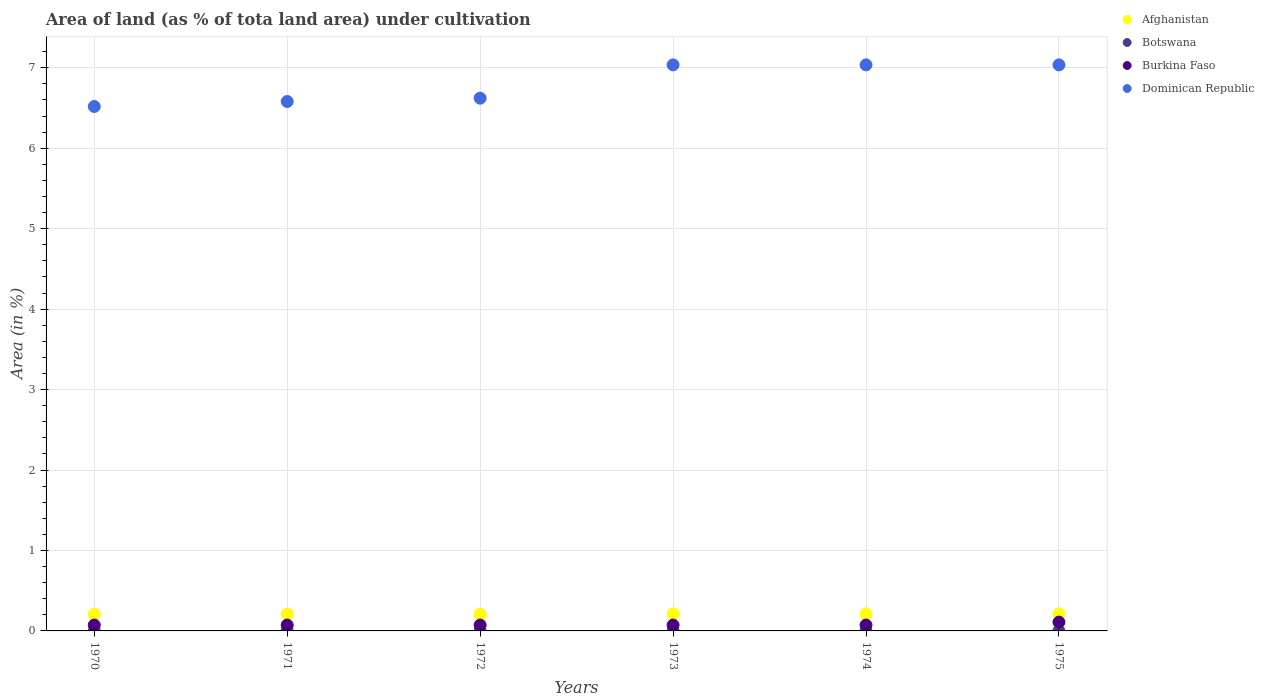What is the percentage of land under cultivation in Botswana in 1974?
Your answer should be compact. 0. Across all years, what is the maximum percentage of land under cultivation in Afghanistan?
Your response must be concise. 0.21. Across all years, what is the minimum percentage of land under cultivation in Dominican Republic?
Offer a terse response. 6.52. What is the total percentage of land under cultivation in Afghanistan in the graph?
Your answer should be very brief. 1.26. What is the difference between the percentage of land under cultivation in Afghanistan in 1973 and that in 1974?
Offer a terse response. 0. What is the difference between the percentage of land under cultivation in Burkina Faso in 1972 and the percentage of land under cultivation in Afghanistan in 1974?
Your response must be concise. -0.14. What is the average percentage of land under cultivation in Burkina Faso per year?
Your answer should be compact. 0.08. In the year 1973, what is the difference between the percentage of land under cultivation in Burkina Faso and percentage of land under cultivation in Dominican Republic?
Provide a short and direct response. -6.96. Is the difference between the percentage of land under cultivation in Burkina Faso in 1972 and 1975 greater than the difference between the percentage of land under cultivation in Dominican Republic in 1972 and 1975?
Provide a succinct answer. Yes. What is the difference between the highest and the second highest percentage of land under cultivation in Burkina Faso?
Your response must be concise. 0.04. In how many years, is the percentage of land under cultivation in Afghanistan greater than the average percentage of land under cultivation in Afghanistan taken over all years?
Provide a short and direct response. 3. Is the sum of the percentage of land under cultivation in Afghanistan in 1970 and 1974 greater than the maximum percentage of land under cultivation in Dominican Republic across all years?
Offer a terse response. No. Is it the case that in every year, the sum of the percentage of land under cultivation in Burkina Faso and percentage of land under cultivation in Dominican Republic  is greater than the sum of percentage of land under cultivation in Botswana and percentage of land under cultivation in Afghanistan?
Your answer should be very brief. No. Is it the case that in every year, the sum of the percentage of land under cultivation in Afghanistan and percentage of land under cultivation in Burkina Faso  is greater than the percentage of land under cultivation in Dominican Republic?
Keep it short and to the point. No. Is the percentage of land under cultivation in Botswana strictly greater than the percentage of land under cultivation in Burkina Faso over the years?
Provide a short and direct response. No. How many dotlines are there?
Provide a succinct answer. 4. How many years are there in the graph?
Provide a short and direct response. 6. Does the graph contain grids?
Your response must be concise. Yes. Where does the legend appear in the graph?
Your response must be concise. Top right. How many legend labels are there?
Ensure brevity in your answer.  4. How are the legend labels stacked?
Make the answer very short. Vertical. What is the title of the graph?
Provide a short and direct response. Area of land (as % of tota land area) under cultivation. Does "Samoa" appear as one of the legend labels in the graph?
Keep it short and to the point. No. What is the label or title of the X-axis?
Your response must be concise. Years. What is the label or title of the Y-axis?
Your response must be concise. Area (in %). What is the Area (in %) of Afghanistan in 1970?
Keep it short and to the point. 0.21. What is the Area (in %) in Botswana in 1970?
Offer a terse response. 0. What is the Area (in %) in Burkina Faso in 1970?
Your answer should be compact. 0.07. What is the Area (in %) in Dominican Republic in 1970?
Offer a terse response. 6.52. What is the Area (in %) in Afghanistan in 1971?
Your answer should be very brief. 0.21. What is the Area (in %) of Botswana in 1971?
Your answer should be compact. 0. What is the Area (in %) of Burkina Faso in 1971?
Provide a short and direct response. 0.07. What is the Area (in %) of Dominican Republic in 1971?
Make the answer very short. 6.58. What is the Area (in %) in Afghanistan in 1972?
Make the answer very short. 0.21. What is the Area (in %) in Botswana in 1972?
Your answer should be compact. 0. What is the Area (in %) of Burkina Faso in 1972?
Give a very brief answer. 0.07. What is the Area (in %) in Dominican Republic in 1972?
Make the answer very short. 6.62. What is the Area (in %) in Afghanistan in 1973?
Offer a terse response. 0.21. What is the Area (in %) in Botswana in 1973?
Provide a short and direct response. 0. What is the Area (in %) of Burkina Faso in 1973?
Provide a short and direct response. 0.07. What is the Area (in %) of Dominican Republic in 1973?
Give a very brief answer. 7.04. What is the Area (in %) of Afghanistan in 1974?
Keep it short and to the point. 0.21. What is the Area (in %) in Botswana in 1974?
Keep it short and to the point. 0. What is the Area (in %) in Burkina Faso in 1974?
Make the answer very short. 0.07. What is the Area (in %) of Dominican Republic in 1974?
Your answer should be compact. 7.04. What is the Area (in %) of Afghanistan in 1975?
Offer a terse response. 0.21. What is the Area (in %) in Botswana in 1975?
Provide a succinct answer. 0. What is the Area (in %) of Burkina Faso in 1975?
Ensure brevity in your answer.  0.11. What is the Area (in %) of Dominican Republic in 1975?
Ensure brevity in your answer.  7.04. Across all years, what is the maximum Area (in %) in Afghanistan?
Ensure brevity in your answer.  0.21. Across all years, what is the maximum Area (in %) in Botswana?
Provide a short and direct response. 0. Across all years, what is the maximum Area (in %) of Burkina Faso?
Offer a very short reply. 0.11. Across all years, what is the maximum Area (in %) of Dominican Republic?
Your answer should be compact. 7.04. Across all years, what is the minimum Area (in %) of Afghanistan?
Provide a succinct answer. 0.21. Across all years, what is the minimum Area (in %) of Botswana?
Give a very brief answer. 0. Across all years, what is the minimum Area (in %) in Burkina Faso?
Provide a short and direct response. 0.07. Across all years, what is the minimum Area (in %) in Dominican Republic?
Your answer should be very brief. 6.52. What is the total Area (in %) of Afghanistan in the graph?
Give a very brief answer. 1.26. What is the total Area (in %) of Botswana in the graph?
Your answer should be very brief. 0.01. What is the total Area (in %) in Burkina Faso in the graph?
Make the answer very short. 0.48. What is the total Area (in %) in Dominican Republic in the graph?
Your answer should be very brief. 40.83. What is the difference between the Area (in %) in Afghanistan in 1970 and that in 1971?
Your answer should be compact. 0. What is the difference between the Area (in %) in Botswana in 1970 and that in 1971?
Provide a succinct answer. 0. What is the difference between the Area (in %) of Burkina Faso in 1970 and that in 1971?
Keep it short and to the point. 0. What is the difference between the Area (in %) of Dominican Republic in 1970 and that in 1971?
Offer a very short reply. -0.06. What is the difference between the Area (in %) in Botswana in 1970 and that in 1972?
Provide a short and direct response. 0. What is the difference between the Area (in %) in Burkina Faso in 1970 and that in 1972?
Your answer should be very brief. 0. What is the difference between the Area (in %) in Dominican Republic in 1970 and that in 1972?
Offer a very short reply. -0.1. What is the difference between the Area (in %) of Afghanistan in 1970 and that in 1973?
Provide a succinct answer. -0. What is the difference between the Area (in %) in Botswana in 1970 and that in 1973?
Offer a terse response. 0. What is the difference between the Area (in %) of Dominican Republic in 1970 and that in 1973?
Offer a very short reply. -0.52. What is the difference between the Area (in %) in Afghanistan in 1970 and that in 1974?
Provide a succinct answer. -0. What is the difference between the Area (in %) of Dominican Republic in 1970 and that in 1974?
Your answer should be compact. -0.52. What is the difference between the Area (in %) in Afghanistan in 1970 and that in 1975?
Ensure brevity in your answer.  -0. What is the difference between the Area (in %) in Botswana in 1970 and that in 1975?
Ensure brevity in your answer.  0. What is the difference between the Area (in %) in Burkina Faso in 1970 and that in 1975?
Offer a very short reply. -0.04. What is the difference between the Area (in %) in Dominican Republic in 1970 and that in 1975?
Your response must be concise. -0.52. What is the difference between the Area (in %) of Afghanistan in 1971 and that in 1972?
Make the answer very short. 0. What is the difference between the Area (in %) of Botswana in 1971 and that in 1972?
Give a very brief answer. 0. What is the difference between the Area (in %) in Dominican Republic in 1971 and that in 1972?
Provide a short and direct response. -0.04. What is the difference between the Area (in %) in Afghanistan in 1971 and that in 1973?
Offer a terse response. -0. What is the difference between the Area (in %) in Dominican Republic in 1971 and that in 1973?
Offer a terse response. -0.46. What is the difference between the Area (in %) in Afghanistan in 1971 and that in 1974?
Keep it short and to the point. -0. What is the difference between the Area (in %) in Botswana in 1971 and that in 1974?
Offer a terse response. 0. What is the difference between the Area (in %) of Burkina Faso in 1971 and that in 1974?
Your response must be concise. 0. What is the difference between the Area (in %) of Dominican Republic in 1971 and that in 1974?
Give a very brief answer. -0.46. What is the difference between the Area (in %) in Afghanistan in 1971 and that in 1975?
Ensure brevity in your answer.  -0. What is the difference between the Area (in %) in Burkina Faso in 1971 and that in 1975?
Provide a succinct answer. -0.04. What is the difference between the Area (in %) in Dominican Republic in 1971 and that in 1975?
Make the answer very short. -0.46. What is the difference between the Area (in %) in Afghanistan in 1972 and that in 1973?
Keep it short and to the point. -0. What is the difference between the Area (in %) of Dominican Republic in 1972 and that in 1973?
Your answer should be compact. -0.41. What is the difference between the Area (in %) in Afghanistan in 1972 and that in 1974?
Keep it short and to the point. -0. What is the difference between the Area (in %) in Botswana in 1972 and that in 1974?
Your answer should be compact. 0. What is the difference between the Area (in %) of Burkina Faso in 1972 and that in 1974?
Offer a very short reply. 0. What is the difference between the Area (in %) in Dominican Republic in 1972 and that in 1974?
Offer a very short reply. -0.41. What is the difference between the Area (in %) of Afghanistan in 1972 and that in 1975?
Keep it short and to the point. -0. What is the difference between the Area (in %) in Botswana in 1972 and that in 1975?
Offer a very short reply. 0. What is the difference between the Area (in %) in Burkina Faso in 1972 and that in 1975?
Provide a short and direct response. -0.04. What is the difference between the Area (in %) in Dominican Republic in 1972 and that in 1975?
Offer a terse response. -0.41. What is the difference between the Area (in %) in Afghanistan in 1973 and that in 1974?
Make the answer very short. 0. What is the difference between the Area (in %) in Burkina Faso in 1973 and that in 1974?
Offer a terse response. 0. What is the difference between the Area (in %) in Afghanistan in 1973 and that in 1975?
Offer a very short reply. 0. What is the difference between the Area (in %) of Burkina Faso in 1973 and that in 1975?
Offer a very short reply. -0.04. What is the difference between the Area (in %) in Afghanistan in 1974 and that in 1975?
Ensure brevity in your answer.  0. What is the difference between the Area (in %) of Botswana in 1974 and that in 1975?
Offer a terse response. 0. What is the difference between the Area (in %) of Burkina Faso in 1974 and that in 1975?
Offer a very short reply. -0.04. What is the difference between the Area (in %) of Afghanistan in 1970 and the Area (in %) of Botswana in 1971?
Your answer should be very brief. 0.21. What is the difference between the Area (in %) of Afghanistan in 1970 and the Area (in %) of Burkina Faso in 1971?
Provide a short and direct response. 0.14. What is the difference between the Area (in %) of Afghanistan in 1970 and the Area (in %) of Dominican Republic in 1971?
Provide a succinct answer. -6.37. What is the difference between the Area (in %) in Botswana in 1970 and the Area (in %) in Burkina Faso in 1971?
Your answer should be compact. -0.07. What is the difference between the Area (in %) in Botswana in 1970 and the Area (in %) in Dominican Republic in 1971?
Give a very brief answer. -6.58. What is the difference between the Area (in %) in Burkina Faso in 1970 and the Area (in %) in Dominican Republic in 1971?
Provide a succinct answer. -6.51. What is the difference between the Area (in %) of Afghanistan in 1970 and the Area (in %) of Botswana in 1972?
Offer a terse response. 0.21. What is the difference between the Area (in %) in Afghanistan in 1970 and the Area (in %) in Burkina Faso in 1972?
Ensure brevity in your answer.  0.14. What is the difference between the Area (in %) in Afghanistan in 1970 and the Area (in %) in Dominican Republic in 1972?
Make the answer very short. -6.41. What is the difference between the Area (in %) in Botswana in 1970 and the Area (in %) in Burkina Faso in 1972?
Make the answer very short. -0.07. What is the difference between the Area (in %) of Botswana in 1970 and the Area (in %) of Dominican Republic in 1972?
Keep it short and to the point. -6.62. What is the difference between the Area (in %) in Burkina Faso in 1970 and the Area (in %) in Dominican Republic in 1972?
Provide a short and direct response. -6.55. What is the difference between the Area (in %) in Afghanistan in 1970 and the Area (in %) in Botswana in 1973?
Offer a very short reply. 0.21. What is the difference between the Area (in %) of Afghanistan in 1970 and the Area (in %) of Burkina Faso in 1973?
Keep it short and to the point. 0.14. What is the difference between the Area (in %) in Afghanistan in 1970 and the Area (in %) in Dominican Republic in 1973?
Give a very brief answer. -6.83. What is the difference between the Area (in %) in Botswana in 1970 and the Area (in %) in Burkina Faso in 1973?
Offer a very short reply. -0.07. What is the difference between the Area (in %) in Botswana in 1970 and the Area (in %) in Dominican Republic in 1973?
Your response must be concise. -7.03. What is the difference between the Area (in %) of Burkina Faso in 1970 and the Area (in %) of Dominican Republic in 1973?
Offer a very short reply. -6.96. What is the difference between the Area (in %) in Afghanistan in 1970 and the Area (in %) in Botswana in 1974?
Your answer should be very brief. 0.21. What is the difference between the Area (in %) of Afghanistan in 1970 and the Area (in %) of Burkina Faso in 1974?
Provide a succinct answer. 0.14. What is the difference between the Area (in %) in Afghanistan in 1970 and the Area (in %) in Dominican Republic in 1974?
Provide a succinct answer. -6.83. What is the difference between the Area (in %) in Botswana in 1970 and the Area (in %) in Burkina Faso in 1974?
Provide a short and direct response. -0.07. What is the difference between the Area (in %) of Botswana in 1970 and the Area (in %) of Dominican Republic in 1974?
Your response must be concise. -7.03. What is the difference between the Area (in %) of Burkina Faso in 1970 and the Area (in %) of Dominican Republic in 1974?
Give a very brief answer. -6.96. What is the difference between the Area (in %) of Afghanistan in 1970 and the Area (in %) of Botswana in 1975?
Keep it short and to the point. 0.21. What is the difference between the Area (in %) of Afghanistan in 1970 and the Area (in %) of Burkina Faso in 1975?
Make the answer very short. 0.1. What is the difference between the Area (in %) of Afghanistan in 1970 and the Area (in %) of Dominican Republic in 1975?
Your answer should be compact. -6.83. What is the difference between the Area (in %) of Botswana in 1970 and the Area (in %) of Burkina Faso in 1975?
Your response must be concise. -0.11. What is the difference between the Area (in %) in Botswana in 1970 and the Area (in %) in Dominican Republic in 1975?
Provide a succinct answer. -7.03. What is the difference between the Area (in %) of Burkina Faso in 1970 and the Area (in %) of Dominican Republic in 1975?
Ensure brevity in your answer.  -6.96. What is the difference between the Area (in %) of Afghanistan in 1971 and the Area (in %) of Botswana in 1972?
Keep it short and to the point. 0.21. What is the difference between the Area (in %) of Afghanistan in 1971 and the Area (in %) of Burkina Faso in 1972?
Keep it short and to the point. 0.14. What is the difference between the Area (in %) in Afghanistan in 1971 and the Area (in %) in Dominican Republic in 1972?
Give a very brief answer. -6.41. What is the difference between the Area (in %) in Botswana in 1971 and the Area (in %) in Burkina Faso in 1972?
Your answer should be compact. -0.07. What is the difference between the Area (in %) of Botswana in 1971 and the Area (in %) of Dominican Republic in 1972?
Provide a short and direct response. -6.62. What is the difference between the Area (in %) of Burkina Faso in 1971 and the Area (in %) of Dominican Republic in 1972?
Give a very brief answer. -6.55. What is the difference between the Area (in %) in Afghanistan in 1971 and the Area (in %) in Botswana in 1973?
Your answer should be compact. 0.21. What is the difference between the Area (in %) in Afghanistan in 1971 and the Area (in %) in Burkina Faso in 1973?
Offer a terse response. 0.14. What is the difference between the Area (in %) in Afghanistan in 1971 and the Area (in %) in Dominican Republic in 1973?
Give a very brief answer. -6.83. What is the difference between the Area (in %) in Botswana in 1971 and the Area (in %) in Burkina Faso in 1973?
Provide a short and direct response. -0.07. What is the difference between the Area (in %) of Botswana in 1971 and the Area (in %) of Dominican Republic in 1973?
Provide a short and direct response. -7.03. What is the difference between the Area (in %) in Burkina Faso in 1971 and the Area (in %) in Dominican Republic in 1973?
Ensure brevity in your answer.  -6.96. What is the difference between the Area (in %) in Afghanistan in 1971 and the Area (in %) in Botswana in 1974?
Keep it short and to the point. 0.21. What is the difference between the Area (in %) in Afghanistan in 1971 and the Area (in %) in Burkina Faso in 1974?
Provide a succinct answer. 0.14. What is the difference between the Area (in %) in Afghanistan in 1971 and the Area (in %) in Dominican Republic in 1974?
Keep it short and to the point. -6.83. What is the difference between the Area (in %) of Botswana in 1971 and the Area (in %) of Burkina Faso in 1974?
Your answer should be compact. -0.07. What is the difference between the Area (in %) of Botswana in 1971 and the Area (in %) of Dominican Republic in 1974?
Keep it short and to the point. -7.03. What is the difference between the Area (in %) in Burkina Faso in 1971 and the Area (in %) in Dominican Republic in 1974?
Your answer should be very brief. -6.96. What is the difference between the Area (in %) of Afghanistan in 1971 and the Area (in %) of Botswana in 1975?
Offer a terse response. 0.21. What is the difference between the Area (in %) in Afghanistan in 1971 and the Area (in %) in Burkina Faso in 1975?
Provide a short and direct response. 0.1. What is the difference between the Area (in %) of Afghanistan in 1971 and the Area (in %) of Dominican Republic in 1975?
Make the answer very short. -6.83. What is the difference between the Area (in %) in Botswana in 1971 and the Area (in %) in Burkina Faso in 1975?
Make the answer very short. -0.11. What is the difference between the Area (in %) of Botswana in 1971 and the Area (in %) of Dominican Republic in 1975?
Give a very brief answer. -7.03. What is the difference between the Area (in %) in Burkina Faso in 1971 and the Area (in %) in Dominican Republic in 1975?
Provide a short and direct response. -6.96. What is the difference between the Area (in %) in Afghanistan in 1972 and the Area (in %) in Botswana in 1973?
Make the answer very short. 0.21. What is the difference between the Area (in %) in Afghanistan in 1972 and the Area (in %) in Burkina Faso in 1973?
Make the answer very short. 0.14. What is the difference between the Area (in %) of Afghanistan in 1972 and the Area (in %) of Dominican Republic in 1973?
Your response must be concise. -6.83. What is the difference between the Area (in %) in Botswana in 1972 and the Area (in %) in Burkina Faso in 1973?
Your answer should be very brief. -0.07. What is the difference between the Area (in %) of Botswana in 1972 and the Area (in %) of Dominican Republic in 1973?
Your answer should be very brief. -7.03. What is the difference between the Area (in %) of Burkina Faso in 1972 and the Area (in %) of Dominican Republic in 1973?
Ensure brevity in your answer.  -6.96. What is the difference between the Area (in %) of Afghanistan in 1972 and the Area (in %) of Botswana in 1974?
Make the answer very short. 0.21. What is the difference between the Area (in %) in Afghanistan in 1972 and the Area (in %) in Burkina Faso in 1974?
Offer a very short reply. 0.14. What is the difference between the Area (in %) in Afghanistan in 1972 and the Area (in %) in Dominican Republic in 1974?
Provide a succinct answer. -6.83. What is the difference between the Area (in %) of Botswana in 1972 and the Area (in %) of Burkina Faso in 1974?
Offer a terse response. -0.07. What is the difference between the Area (in %) of Botswana in 1972 and the Area (in %) of Dominican Republic in 1974?
Your answer should be very brief. -7.03. What is the difference between the Area (in %) of Burkina Faso in 1972 and the Area (in %) of Dominican Republic in 1974?
Provide a short and direct response. -6.96. What is the difference between the Area (in %) of Afghanistan in 1972 and the Area (in %) of Botswana in 1975?
Ensure brevity in your answer.  0.21. What is the difference between the Area (in %) of Afghanistan in 1972 and the Area (in %) of Burkina Faso in 1975?
Make the answer very short. 0.1. What is the difference between the Area (in %) in Afghanistan in 1972 and the Area (in %) in Dominican Republic in 1975?
Your answer should be compact. -6.83. What is the difference between the Area (in %) of Botswana in 1972 and the Area (in %) of Burkina Faso in 1975?
Your answer should be compact. -0.11. What is the difference between the Area (in %) in Botswana in 1972 and the Area (in %) in Dominican Republic in 1975?
Your answer should be compact. -7.03. What is the difference between the Area (in %) in Burkina Faso in 1972 and the Area (in %) in Dominican Republic in 1975?
Offer a terse response. -6.96. What is the difference between the Area (in %) in Afghanistan in 1973 and the Area (in %) in Botswana in 1974?
Your response must be concise. 0.21. What is the difference between the Area (in %) of Afghanistan in 1973 and the Area (in %) of Burkina Faso in 1974?
Give a very brief answer. 0.14. What is the difference between the Area (in %) of Afghanistan in 1973 and the Area (in %) of Dominican Republic in 1974?
Offer a very short reply. -6.83. What is the difference between the Area (in %) of Botswana in 1973 and the Area (in %) of Burkina Faso in 1974?
Offer a terse response. -0.07. What is the difference between the Area (in %) in Botswana in 1973 and the Area (in %) in Dominican Republic in 1974?
Ensure brevity in your answer.  -7.03. What is the difference between the Area (in %) in Burkina Faso in 1973 and the Area (in %) in Dominican Republic in 1974?
Your response must be concise. -6.96. What is the difference between the Area (in %) of Afghanistan in 1973 and the Area (in %) of Botswana in 1975?
Ensure brevity in your answer.  0.21. What is the difference between the Area (in %) of Afghanistan in 1973 and the Area (in %) of Burkina Faso in 1975?
Provide a succinct answer. 0.1. What is the difference between the Area (in %) in Afghanistan in 1973 and the Area (in %) in Dominican Republic in 1975?
Provide a succinct answer. -6.83. What is the difference between the Area (in %) in Botswana in 1973 and the Area (in %) in Burkina Faso in 1975?
Your answer should be compact. -0.11. What is the difference between the Area (in %) of Botswana in 1973 and the Area (in %) of Dominican Republic in 1975?
Your response must be concise. -7.03. What is the difference between the Area (in %) in Burkina Faso in 1973 and the Area (in %) in Dominican Republic in 1975?
Provide a short and direct response. -6.96. What is the difference between the Area (in %) of Afghanistan in 1974 and the Area (in %) of Botswana in 1975?
Make the answer very short. 0.21. What is the difference between the Area (in %) of Afghanistan in 1974 and the Area (in %) of Burkina Faso in 1975?
Your answer should be compact. 0.1. What is the difference between the Area (in %) of Afghanistan in 1974 and the Area (in %) of Dominican Republic in 1975?
Ensure brevity in your answer.  -6.83. What is the difference between the Area (in %) of Botswana in 1974 and the Area (in %) of Burkina Faso in 1975?
Your answer should be very brief. -0.11. What is the difference between the Area (in %) in Botswana in 1974 and the Area (in %) in Dominican Republic in 1975?
Your response must be concise. -7.03. What is the difference between the Area (in %) in Burkina Faso in 1974 and the Area (in %) in Dominican Republic in 1975?
Ensure brevity in your answer.  -6.96. What is the average Area (in %) of Afghanistan per year?
Make the answer very short. 0.21. What is the average Area (in %) of Botswana per year?
Your answer should be compact. 0. What is the average Area (in %) of Burkina Faso per year?
Give a very brief answer. 0.08. What is the average Area (in %) in Dominican Republic per year?
Keep it short and to the point. 6.81. In the year 1970, what is the difference between the Area (in %) in Afghanistan and Area (in %) in Botswana?
Your answer should be compact. 0.21. In the year 1970, what is the difference between the Area (in %) in Afghanistan and Area (in %) in Burkina Faso?
Provide a succinct answer. 0.14. In the year 1970, what is the difference between the Area (in %) in Afghanistan and Area (in %) in Dominican Republic?
Give a very brief answer. -6.31. In the year 1970, what is the difference between the Area (in %) of Botswana and Area (in %) of Burkina Faso?
Keep it short and to the point. -0.07. In the year 1970, what is the difference between the Area (in %) of Botswana and Area (in %) of Dominican Republic?
Provide a succinct answer. -6.52. In the year 1970, what is the difference between the Area (in %) in Burkina Faso and Area (in %) in Dominican Republic?
Provide a succinct answer. -6.45. In the year 1971, what is the difference between the Area (in %) in Afghanistan and Area (in %) in Botswana?
Your response must be concise. 0.21. In the year 1971, what is the difference between the Area (in %) in Afghanistan and Area (in %) in Burkina Faso?
Offer a terse response. 0.14. In the year 1971, what is the difference between the Area (in %) of Afghanistan and Area (in %) of Dominican Republic?
Your response must be concise. -6.37. In the year 1971, what is the difference between the Area (in %) in Botswana and Area (in %) in Burkina Faso?
Give a very brief answer. -0.07. In the year 1971, what is the difference between the Area (in %) of Botswana and Area (in %) of Dominican Republic?
Keep it short and to the point. -6.58. In the year 1971, what is the difference between the Area (in %) in Burkina Faso and Area (in %) in Dominican Republic?
Offer a terse response. -6.51. In the year 1972, what is the difference between the Area (in %) in Afghanistan and Area (in %) in Botswana?
Offer a very short reply. 0.21. In the year 1972, what is the difference between the Area (in %) in Afghanistan and Area (in %) in Burkina Faso?
Give a very brief answer. 0.14. In the year 1972, what is the difference between the Area (in %) of Afghanistan and Area (in %) of Dominican Republic?
Make the answer very short. -6.41. In the year 1972, what is the difference between the Area (in %) of Botswana and Area (in %) of Burkina Faso?
Give a very brief answer. -0.07. In the year 1972, what is the difference between the Area (in %) in Botswana and Area (in %) in Dominican Republic?
Provide a succinct answer. -6.62. In the year 1972, what is the difference between the Area (in %) in Burkina Faso and Area (in %) in Dominican Republic?
Offer a terse response. -6.55. In the year 1973, what is the difference between the Area (in %) in Afghanistan and Area (in %) in Botswana?
Ensure brevity in your answer.  0.21. In the year 1973, what is the difference between the Area (in %) in Afghanistan and Area (in %) in Burkina Faso?
Ensure brevity in your answer.  0.14. In the year 1973, what is the difference between the Area (in %) in Afghanistan and Area (in %) in Dominican Republic?
Provide a succinct answer. -6.83. In the year 1973, what is the difference between the Area (in %) in Botswana and Area (in %) in Burkina Faso?
Your response must be concise. -0.07. In the year 1973, what is the difference between the Area (in %) in Botswana and Area (in %) in Dominican Republic?
Your response must be concise. -7.03. In the year 1973, what is the difference between the Area (in %) of Burkina Faso and Area (in %) of Dominican Republic?
Provide a succinct answer. -6.96. In the year 1974, what is the difference between the Area (in %) in Afghanistan and Area (in %) in Botswana?
Provide a succinct answer. 0.21. In the year 1974, what is the difference between the Area (in %) of Afghanistan and Area (in %) of Burkina Faso?
Your answer should be compact. 0.14. In the year 1974, what is the difference between the Area (in %) of Afghanistan and Area (in %) of Dominican Republic?
Provide a short and direct response. -6.83. In the year 1974, what is the difference between the Area (in %) in Botswana and Area (in %) in Burkina Faso?
Offer a very short reply. -0.07. In the year 1974, what is the difference between the Area (in %) of Botswana and Area (in %) of Dominican Republic?
Offer a very short reply. -7.03. In the year 1974, what is the difference between the Area (in %) of Burkina Faso and Area (in %) of Dominican Republic?
Offer a very short reply. -6.96. In the year 1975, what is the difference between the Area (in %) of Afghanistan and Area (in %) of Botswana?
Offer a terse response. 0.21. In the year 1975, what is the difference between the Area (in %) of Afghanistan and Area (in %) of Burkina Faso?
Provide a short and direct response. 0.1. In the year 1975, what is the difference between the Area (in %) of Afghanistan and Area (in %) of Dominican Republic?
Your response must be concise. -6.83. In the year 1975, what is the difference between the Area (in %) in Botswana and Area (in %) in Burkina Faso?
Keep it short and to the point. -0.11. In the year 1975, what is the difference between the Area (in %) of Botswana and Area (in %) of Dominican Republic?
Keep it short and to the point. -7.03. In the year 1975, what is the difference between the Area (in %) in Burkina Faso and Area (in %) in Dominican Republic?
Make the answer very short. -6.93. What is the ratio of the Area (in %) in Afghanistan in 1970 to that in 1971?
Provide a succinct answer. 1. What is the ratio of the Area (in %) of Botswana in 1970 to that in 1971?
Offer a terse response. 1. What is the ratio of the Area (in %) of Burkina Faso in 1970 to that in 1971?
Give a very brief answer. 1. What is the ratio of the Area (in %) of Dominican Republic in 1970 to that in 1971?
Keep it short and to the point. 0.99. What is the ratio of the Area (in %) in Dominican Republic in 1970 to that in 1972?
Keep it short and to the point. 0.98. What is the ratio of the Area (in %) in Afghanistan in 1970 to that in 1973?
Your answer should be very brief. 0.99. What is the ratio of the Area (in %) of Burkina Faso in 1970 to that in 1973?
Keep it short and to the point. 1. What is the ratio of the Area (in %) in Dominican Republic in 1970 to that in 1973?
Your answer should be compact. 0.93. What is the ratio of the Area (in %) in Afghanistan in 1970 to that in 1974?
Ensure brevity in your answer.  0.99. What is the ratio of the Area (in %) in Botswana in 1970 to that in 1974?
Your response must be concise. 1. What is the ratio of the Area (in %) of Dominican Republic in 1970 to that in 1974?
Provide a succinct answer. 0.93. What is the ratio of the Area (in %) in Afghanistan in 1970 to that in 1975?
Offer a very short reply. 0.99. What is the ratio of the Area (in %) in Botswana in 1970 to that in 1975?
Make the answer very short. 1. What is the ratio of the Area (in %) in Dominican Republic in 1970 to that in 1975?
Keep it short and to the point. 0.93. What is the ratio of the Area (in %) in Burkina Faso in 1971 to that in 1972?
Your answer should be compact. 1. What is the ratio of the Area (in %) of Afghanistan in 1971 to that in 1973?
Provide a succinct answer. 0.99. What is the ratio of the Area (in %) of Botswana in 1971 to that in 1973?
Your answer should be very brief. 1. What is the ratio of the Area (in %) of Dominican Republic in 1971 to that in 1973?
Keep it short and to the point. 0.94. What is the ratio of the Area (in %) in Afghanistan in 1971 to that in 1974?
Keep it short and to the point. 0.99. What is the ratio of the Area (in %) of Burkina Faso in 1971 to that in 1974?
Offer a terse response. 1. What is the ratio of the Area (in %) in Dominican Republic in 1971 to that in 1974?
Your response must be concise. 0.94. What is the ratio of the Area (in %) of Afghanistan in 1971 to that in 1975?
Give a very brief answer. 0.99. What is the ratio of the Area (in %) of Botswana in 1971 to that in 1975?
Give a very brief answer. 1. What is the ratio of the Area (in %) in Burkina Faso in 1971 to that in 1975?
Your answer should be compact. 0.67. What is the ratio of the Area (in %) of Dominican Republic in 1971 to that in 1975?
Make the answer very short. 0.94. What is the ratio of the Area (in %) in Afghanistan in 1972 to that in 1973?
Your answer should be very brief. 0.99. What is the ratio of the Area (in %) in Botswana in 1972 to that in 1973?
Your answer should be compact. 1. What is the ratio of the Area (in %) of Afghanistan in 1972 to that in 1974?
Provide a succinct answer. 0.99. What is the ratio of the Area (in %) in Burkina Faso in 1972 to that in 1974?
Your answer should be compact. 1. What is the ratio of the Area (in %) in Dominican Republic in 1972 to that in 1974?
Keep it short and to the point. 0.94. What is the ratio of the Area (in %) in Afghanistan in 1972 to that in 1975?
Provide a short and direct response. 0.99. What is the ratio of the Area (in %) in Botswana in 1973 to that in 1974?
Offer a very short reply. 1. What is the ratio of the Area (in %) in Dominican Republic in 1973 to that in 1974?
Your answer should be very brief. 1. What is the ratio of the Area (in %) in Afghanistan in 1973 to that in 1975?
Provide a short and direct response. 1. What is the ratio of the Area (in %) in Burkina Faso in 1973 to that in 1975?
Ensure brevity in your answer.  0.67. What is the ratio of the Area (in %) of Dominican Republic in 1973 to that in 1975?
Provide a succinct answer. 1. What is the ratio of the Area (in %) of Botswana in 1974 to that in 1975?
Your response must be concise. 1. What is the ratio of the Area (in %) of Burkina Faso in 1974 to that in 1975?
Provide a short and direct response. 0.67. What is the difference between the highest and the second highest Area (in %) of Afghanistan?
Offer a very short reply. 0. What is the difference between the highest and the second highest Area (in %) in Botswana?
Provide a short and direct response. 0. What is the difference between the highest and the second highest Area (in %) of Burkina Faso?
Your response must be concise. 0.04. What is the difference between the highest and the lowest Area (in %) of Afghanistan?
Ensure brevity in your answer.  0. What is the difference between the highest and the lowest Area (in %) of Burkina Faso?
Your response must be concise. 0.04. What is the difference between the highest and the lowest Area (in %) in Dominican Republic?
Ensure brevity in your answer.  0.52. 